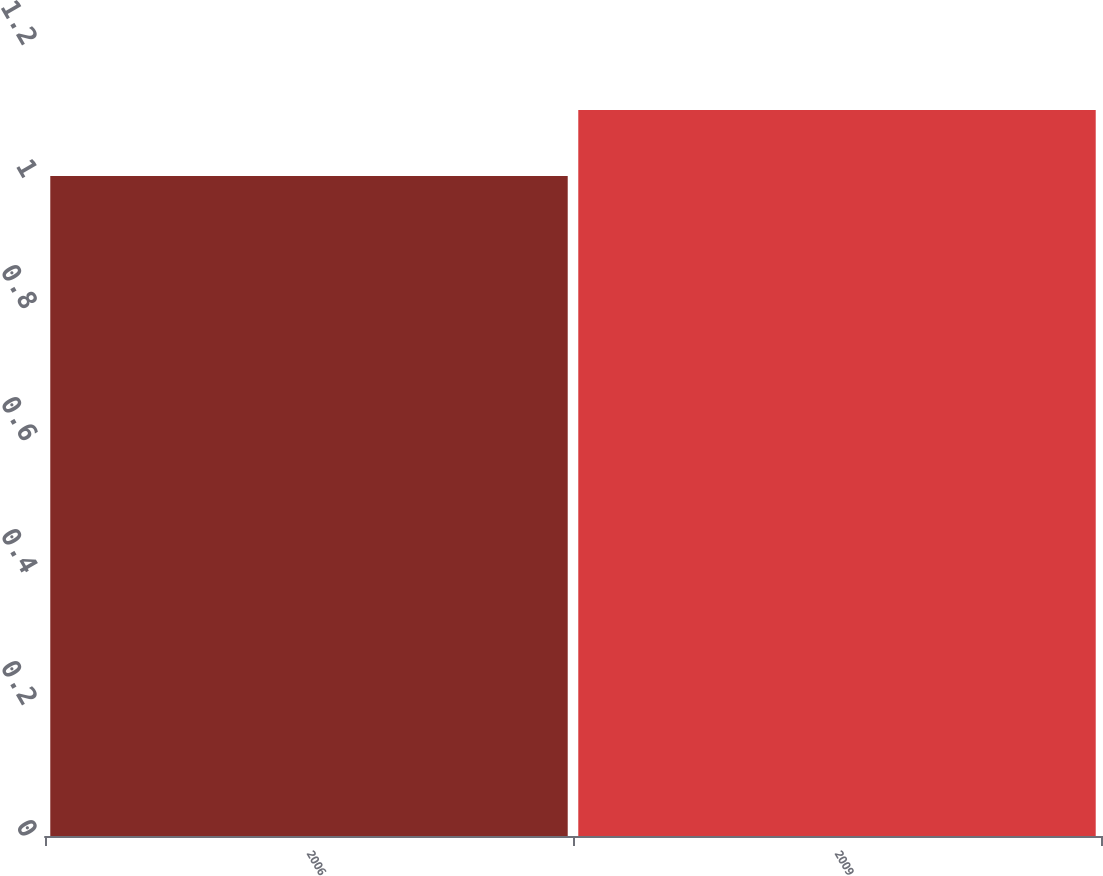Convert chart. <chart><loc_0><loc_0><loc_500><loc_500><bar_chart><fcel>2006<fcel>2009<nl><fcel>1<fcel>1.1<nl></chart> 